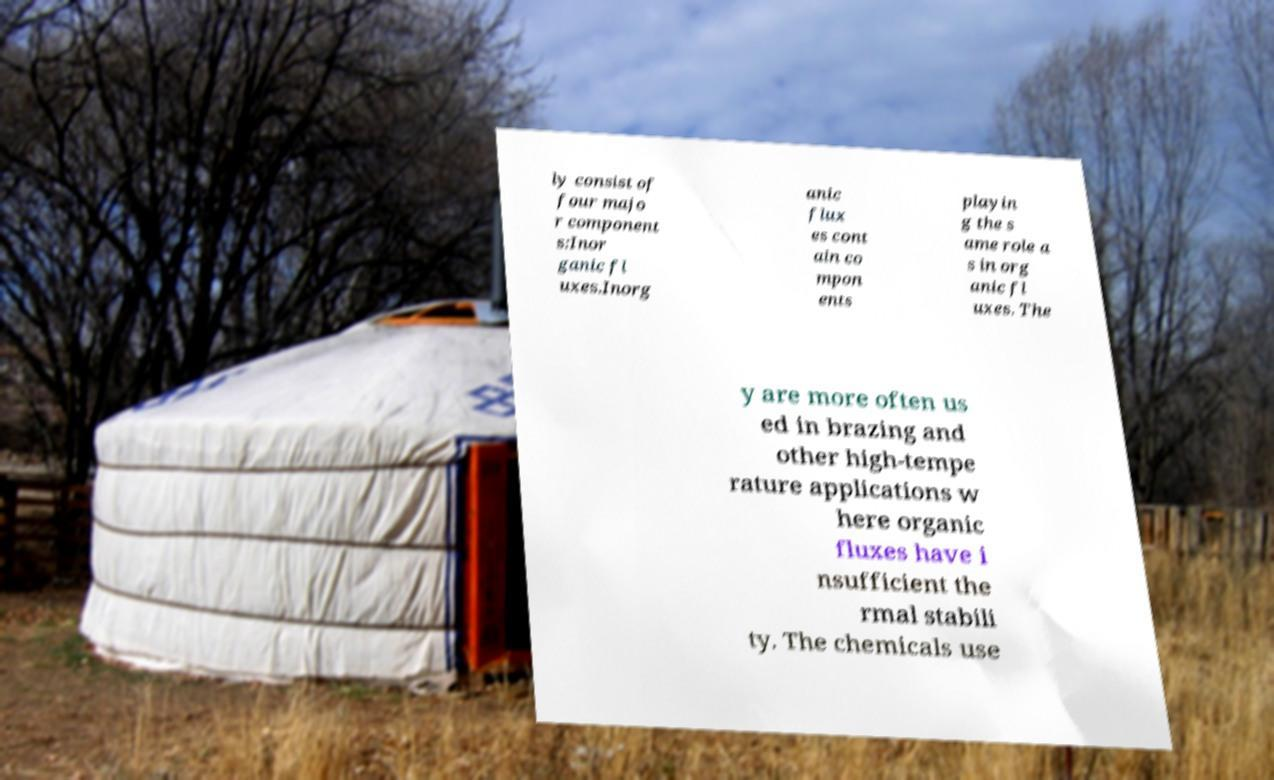Can you accurately transcribe the text from the provided image for me? ly consist of four majo r component s:Inor ganic fl uxes.Inorg anic flux es cont ain co mpon ents playin g the s ame role a s in org anic fl uxes. The y are more often us ed in brazing and other high-tempe rature applications w here organic fluxes have i nsufficient the rmal stabili ty. The chemicals use 